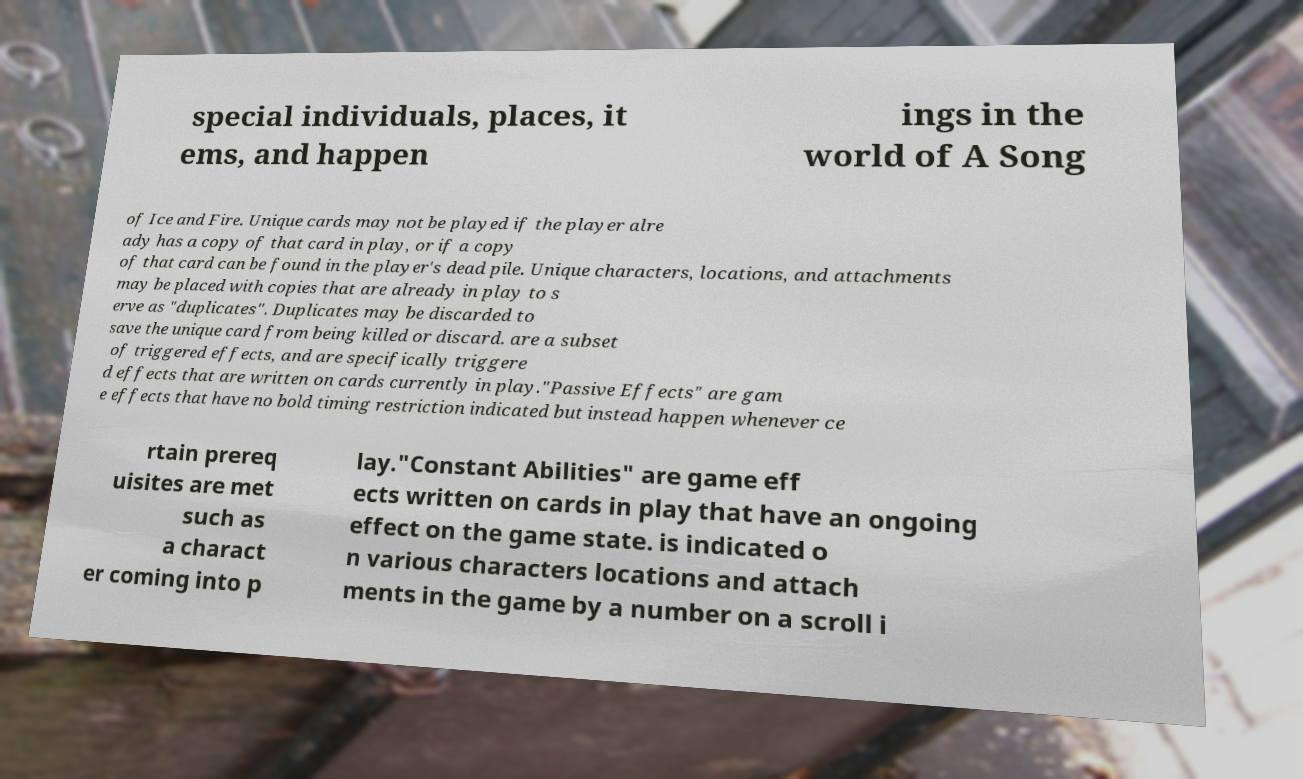Can you read and provide the text displayed in the image?This photo seems to have some interesting text. Can you extract and type it out for me? special individuals, places, it ems, and happen ings in the world of A Song of Ice and Fire. Unique cards may not be played if the player alre ady has a copy of that card in play, or if a copy of that card can be found in the player's dead pile. Unique characters, locations, and attachments may be placed with copies that are already in play to s erve as "duplicates". Duplicates may be discarded to save the unique card from being killed or discard. are a subset of triggered effects, and are specifically triggere d effects that are written on cards currently in play."Passive Effects" are gam e effects that have no bold timing restriction indicated but instead happen whenever ce rtain prereq uisites are met such as a charact er coming into p lay."Constant Abilities" are game eff ects written on cards in play that have an ongoing effect on the game state. is indicated o n various characters locations and attach ments in the game by a number on a scroll i 